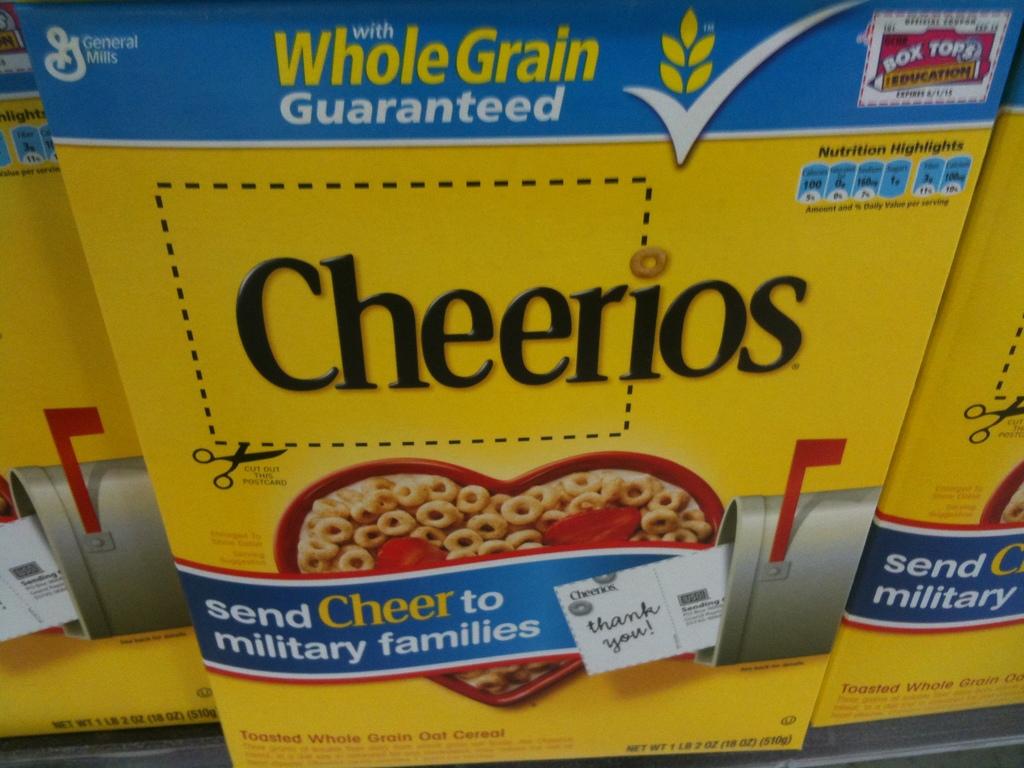What is the name of the cereal?
Give a very brief answer. Cheerios. What type of cereal is this?
Offer a very short reply. Cheerios. 